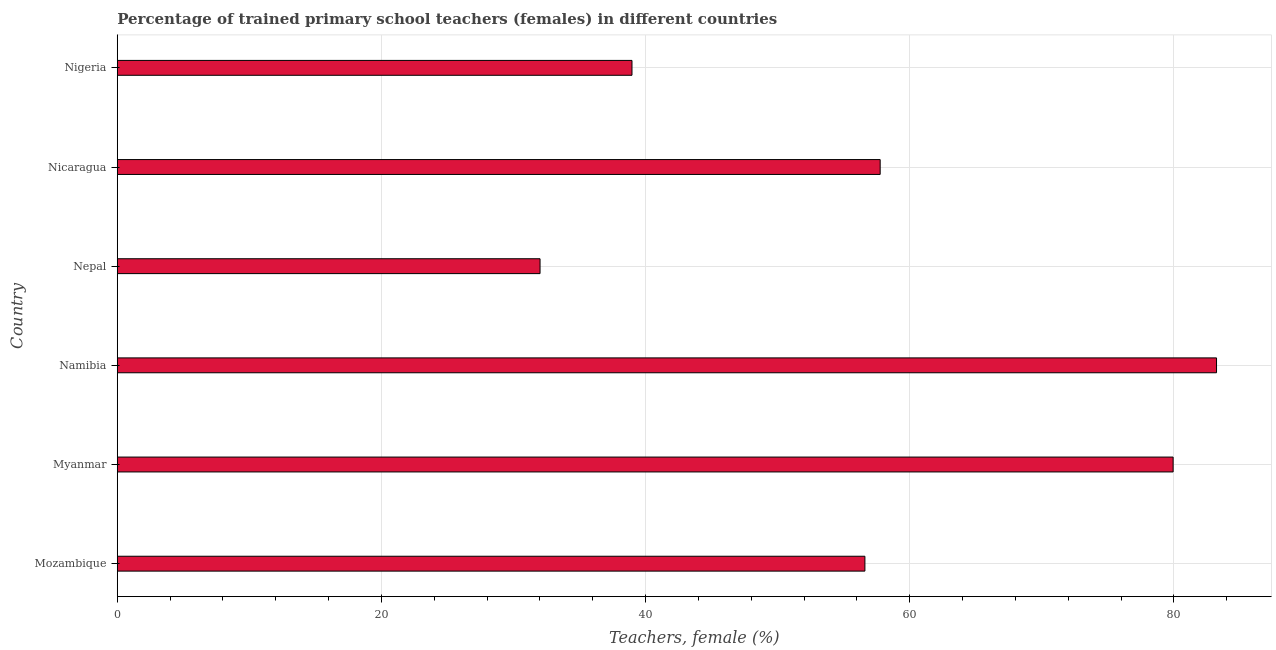What is the title of the graph?
Your answer should be very brief. Percentage of trained primary school teachers (females) in different countries. What is the label or title of the X-axis?
Offer a very short reply. Teachers, female (%). What is the label or title of the Y-axis?
Keep it short and to the point. Country. What is the percentage of trained female teachers in Myanmar?
Your answer should be very brief. 79.94. Across all countries, what is the maximum percentage of trained female teachers?
Offer a terse response. 83.23. Across all countries, what is the minimum percentage of trained female teachers?
Your response must be concise. 32.01. In which country was the percentage of trained female teachers maximum?
Keep it short and to the point. Namibia. In which country was the percentage of trained female teachers minimum?
Your answer should be compact. Nepal. What is the sum of the percentage of trained female teachers?
Offer a very short reply. 348.51. What is the difference between the percentage of trained female teachers in Myanmar and Nicaragua?
Your answer should be very brief. 22.18. What is the average percentage of trained female teachers per country?
Offer a terse response. 58.08. What is the median percentage of trained female teachers?
Offer a very short reply. 57.18. In how many countries, is the percentage of trained female teachers greater than 20 %?
Keep it short and to the point. 6. What is the ratio of the percentage of trained female teachers in Mozambique to that in Nepal?
Offer a very short reply. 1.77. What is the difference between the highest and the second highest percentage of trained female teachers?
Offer a very short reply. 3.29. Is the sum of the percentage of trained female teachers in Namibia and Nicaragua greater than the maximum percentage of trained female teachers across all countries?
Your answer should be compact. Yes. What is the difference between the highest and the lowest percentage of trained female teachers?
Your answer should be very brief. 51.22. Are all the bars in the graph horizontal?
Your answer should be compact. Yes. How many countries are there in the graph?
Ensure brevity in your answer.  6. Are the values on the major ticks of X-axis written in scientific E-notation?
Your answer should be very brief. No. What is the Teachers, female (%) of Mozambique?
Your answer should be compact. 56.6. What is the Teachers, female (%) in Myanmar?
Ensure brevity in your answer.  79.94. What is the Teachers, female (%) in Namibia?
Your answer should be very brief. 83.23. What is the Teachers, female (%) of Nepal?
Make the answer very short. 32.01. What is the Teachers, female (%) in Nicaragua?
Keep it short and to the point. 57.76. What is the Teachers, female (%) in Nigeria?
Offer a terse response. 38.97. What is the difference between the Teachers, female (%) in Mozambique and Myanmar?
Your answer should be very brief. -23.34. What is the difference between the Teachers, female (%) in Mozambique and Namibia?
Your answer should be compact. -26.62. What is the difference between the Teachers, female (%) in Mozambique and Nepal?
Your answer should be compact. 24.6. What is the difference between the Teachers, female (%) in Mozambique and Nicaragua?
Your answer should be compact. -1.16. What is the difference between the Teachers, female (%) in Mozambique and Nigeria?
Make the answer very short. 17.63. What is the difference between the Teachers, female (%) in Myanmar and Namibia?
Your answer should be compact. -3.29. What is the difference between the Teachers, female (%) in Myanmar and Nepal?
Your answer should be compact. 47.93. What is the difference between the Teachers, female (%) in Myanmar and Nicaragua?
Ensure brevity in your answer.  22.18. What is the difference between the Teachers, female (%) in Myanmar and Nigeria?
Provide a succinct answer. 40.97. What is the difference between the Teachers, female (%) in Namibia and Nepal?
Offer a very short reply. 51.22. What is the difference between the Teachers, female (%) in Namibia and Nicaragua?
Ensure brevity in your answer.  25.47. What is the difference between the Teachers, female (%) in Namibia and Nigeria?
Your answer should be very brief. 44.26. What is the difference between the Teachers, female (%) in Nepal and Nicaragua?
Provide a succinct answer. -25.75. What is the difference between the Teachers, female (%) in Nepal and Nigeria?
Offer a terse response. -6.96. What is the difference between the Teachers, female (%) in Nicaragua and Nigeria?
Make the answer very short. 18.79. What is the ratio of the Teachers, female (%) in Mozambique to that in Myanmar?
Your answer should be compact. 0.71. What is the ratio of the Teachers, female (%) in Mozambique to that in Namibia?
Offer a terse response. 0.68. What is the ratio of the Teachers, female (%) in Mozambique to that in Nepal?
Offer a very short reply. 1.77. What is the ratio of the Teachers, female (%) in Mozambique to that in Nigeria?
Your answer should be compact. 1.45. What is the ratio of the Teachers, female (%) in Myanmar to that in Nepal?
Keep it short and to the point. 2.5. What is the ratio of the Teachers, female (%) in Myanmar to that in Nicaragua?
Keep it short and to the point. 1.38. What is the ratio of the Teachers, female (%) in Myanmar to that in Nigeria?
Your answer should be very brief. 2.05. What is the ratio of the Teachers, female (%) in Namibia to that in Nepal?
Offer a terse response. 2.6. What is the ratio of the Teachers, female (%) in Namibia to that in Nicaragua?
Your response must be concise. 1.44. What is the ratio of the Teachers, female (%) in Namibia to that in Nigeria?
Offer a very short reply. 2.14. What is the ratio of the Teachers, female (%) in Nepal to that in Nicaragua?
Provide a succinct answer. 0.55. What is the ratio of the Teachers, female (%) in Nepal to that in Nigeria?
Provide a short and direct response. 0.82. What is the ratio of the Teachers, female (%) in Nicaragua to that in Nigeria?
Provide a short and direct response. 1.48. 